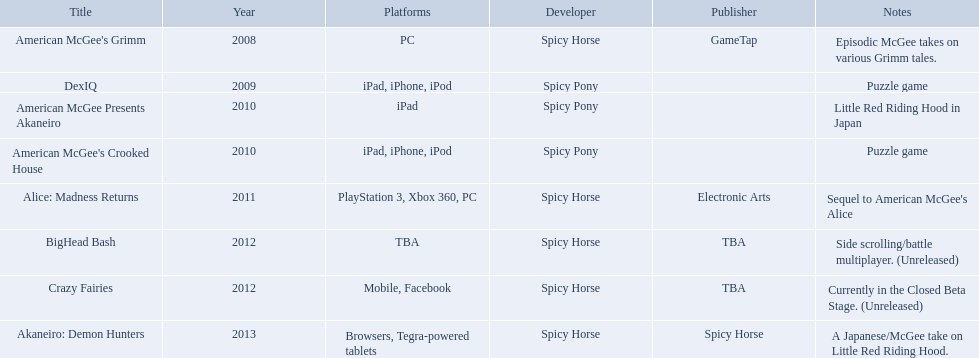Which spicy horse titles are shown? American McGee's Grimm, DexIQ, American McGee Presents Akaneiro, American McGee's Crooked House, Alice: Madness Returns, BigHead Bash, Crazy Fairies, Akaneiro: Demon Hunters. Of those, which are for the ipad? DexIQ, American McGee Presents Akaneiro, American McGee's Crooked House. Which of those are not for the iphone or ipod? American McGee Presents Akaneiro. What are all the titles of games published? American McGee's Grimm, DexIQ, American McGee Presents Akaneiro, American McGee's Crooked House, Alice: Madness Returns, BigHead Bash, Crazy Fairies, Akaneiro: Demon Hunters. What are all the names of the publishers? GameTap, , , , Electronic Arts, TBA, TBA, Spicy Horse. What is the published game title that corresponds to electronic arts? Alice: Madness Returns. What spicy horse games are being presented? American McGee's Grimm, DexIQ, American McGee Presents Akaneiro, American McGee's Crooked House, Alice: Madness Returns, BigHead Bash, Crazy Fairies, Akaneiro: Demon Hunters. From that selection, which are intended for the ipad? DexIQ, American McGee Presents Akaneiro, American McGee's Crooked House. Among these, which aren't supported on the iphone or ipod? American McGee Presents Akaneiro. 